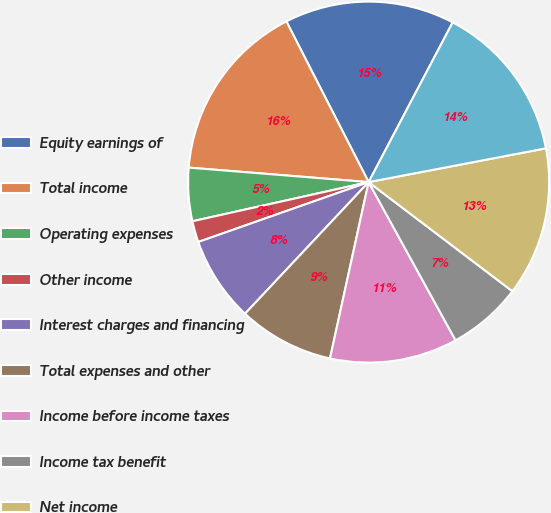Convert chart. <chart><loc_0><loc_0><loc_500><loc_500><pie_chart><fcel>Equity earnings of<fcel>Total income<fcel>Operating expenses<fcel>Other income<fcel>Interest charges and financing<fcel>Total expenses and other<fcel>Income before income taxes<fcel>Income tax benefit<fcel>Net income<fcel>Earnings available to common<nl><fcel>15.24%<fcel>16.19%<fcel>4.76%<fcel>1.9%<fcel>7.62%<fcel>8.57%<fcel>11.43%<fcel>6.67%<fcel>13.33%<fcel>14.29%<nl></chart> 